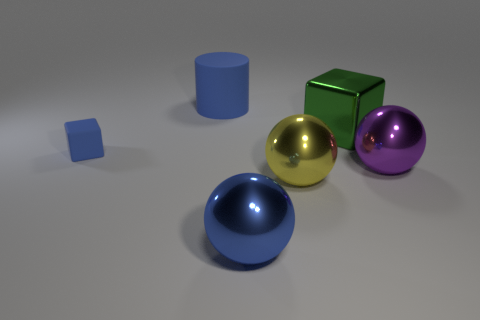Does the rubber thing to the left of the large blue cylinder have the same color as the metallic block?
Make the answer very short. No. What number of other objects are the same color as the big matte cylinder?
Offer a terse response. 2. What number of small objects are either green metallic cubes or cyan rubber blocks?
Ensure brevity in your answer.  0. Is the number of blue cubes greater than the number of blue things?
Make the answer very short. No. Do the yellow thing and the tiny blue object have the same material?
Make the answer very short. No. Is there anything else that has the same material as the blue block?
Your response must be concise. Yes. Are there more blue matte blocks on the right side of the big green metallic thing than large spheres?
Make the answer very short. No. Does the large cylinder have the same color as the big metal cube?
Offer a very short reply. No. How many other metal objects are the same shape as the green thing?
Your answer should be compact. 0. What size is the blue sphere that is made of the same material as the large green block?
Ensure brevity in your answer.  Large. 